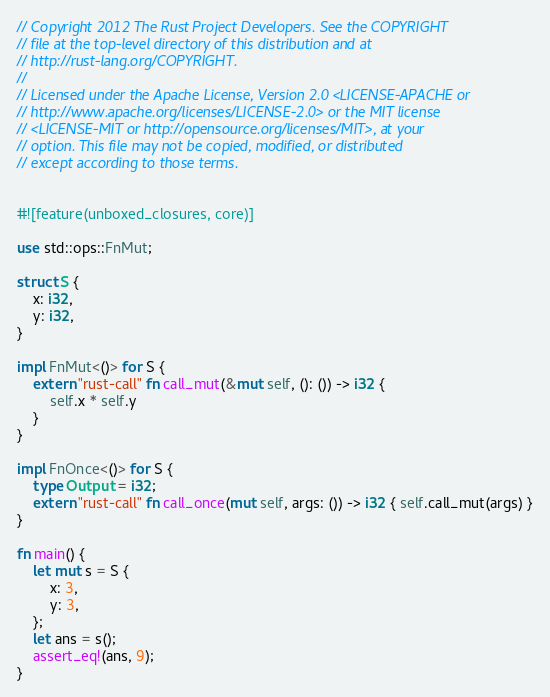<code> <loc_0><loc_0><loc_500><loc_500><_Rust_>// Copyright 2012 The Rust Project Developers. See the COPYRIGHT
// file at the top-level directory of this distribution and at
// http://rust-lang.org/COPYRIGHT.
//
// Licensed under the Apache License, Version 2.0 <LICENSE-APACHE or
// http://www.apache.org/licenses/LICENSE-2.0> or the MIT license
// <LICENSE-MIT or http://opensource.org/licenses/MIT>, at your
// option. This file may not be copied, modified, or distributed
// except according to those terms.


#![feature(unboxed_closures, core)]

use std::ops::FnMut;

struct S {
    x: i32,
    y: i32,
}

impl FnMut<()> for S {
    extern "rust-call" fn call_mut(&mut self, (): ()) -> i32 {
        self.x * self.y
    }
}

impl FnOnce<()> for S {
    type Output = i32;
    extern "rust-call" fn call_once(mut self, args: ()) -> i32 { self.call_mut(args) }
}

fn main() {
    let mut s = S {
        x: 3,
        y: 3,
    };
    let ans = s();
    assert_eq!(ans, 9);
}
</code> 